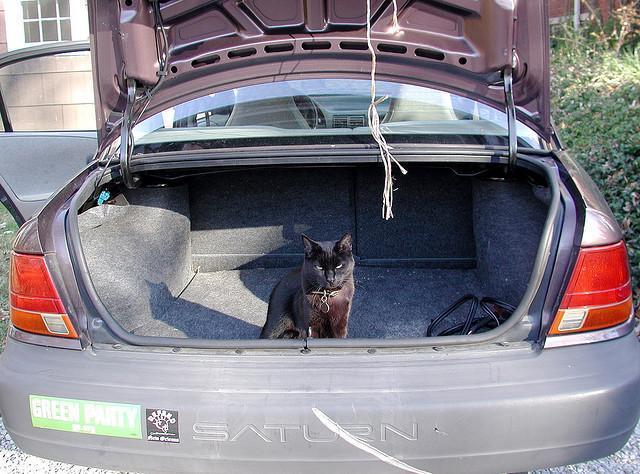How many horses are there?
Give a very brief answer. 0. 